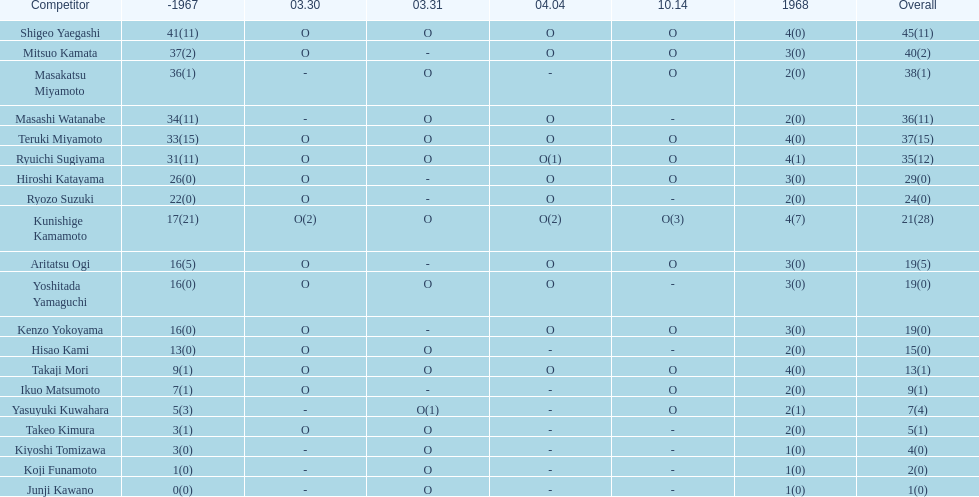How many additional overall appearances did shigeo yaegashi make compared to mitsuo kamata? 5. 